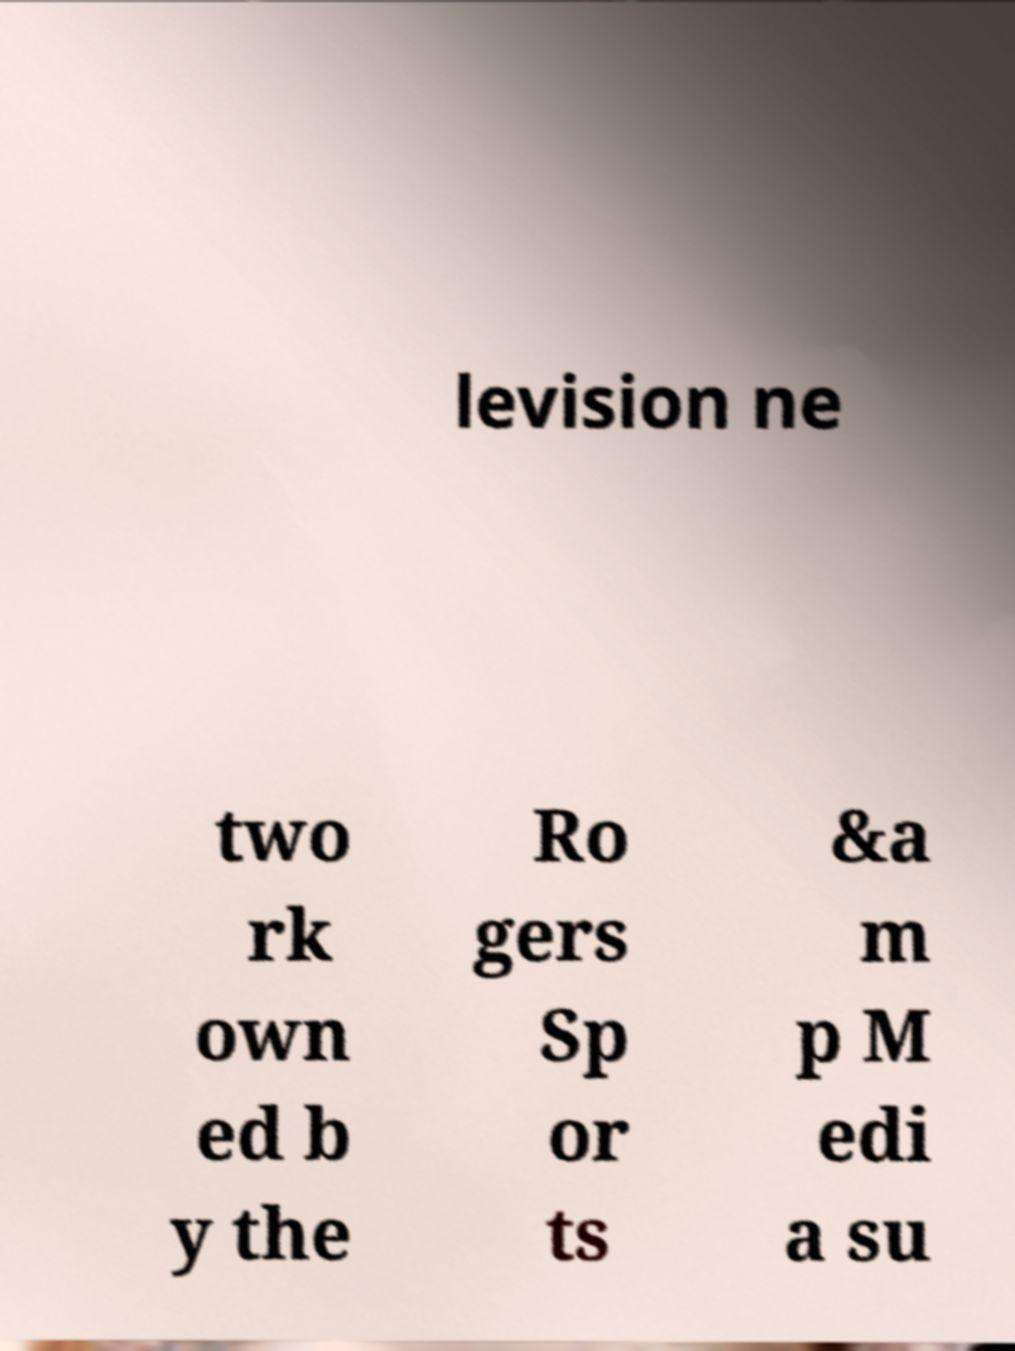Can you read and provide the text displayed in the image?This photo seems to have some interesting text. Can you extract and type it out for me? levision ne two rk own ed b y the Ro gers Sp or ts &a m p M edi a su 